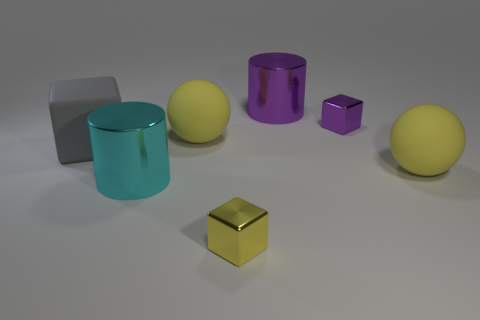Subtract all yellow shiny blocks. How many blocks are left? 2 Add 3 large cyan metallic cylinders. How many objects exist? 10 Subtract all cyan cylinders. How many cylinders are left? 1 Subtract all blocks. How many objects are left? 4 Subtract all brown spheres. Subtract all red cylinders. How many spheres are left? 2 Subtract all red cylinders. How many blue spheres are left? 0 Subtract all big red things. Subtract all gray things. How many objects are left? 6 Add 1 small yellow objects. How many small yellow objects are left? 2 Add 1 big purple shiny cylinders. How many big purple shiny cylinders exist? 2 Subtract 0 yellow cylinders. How many objects are left? 7 